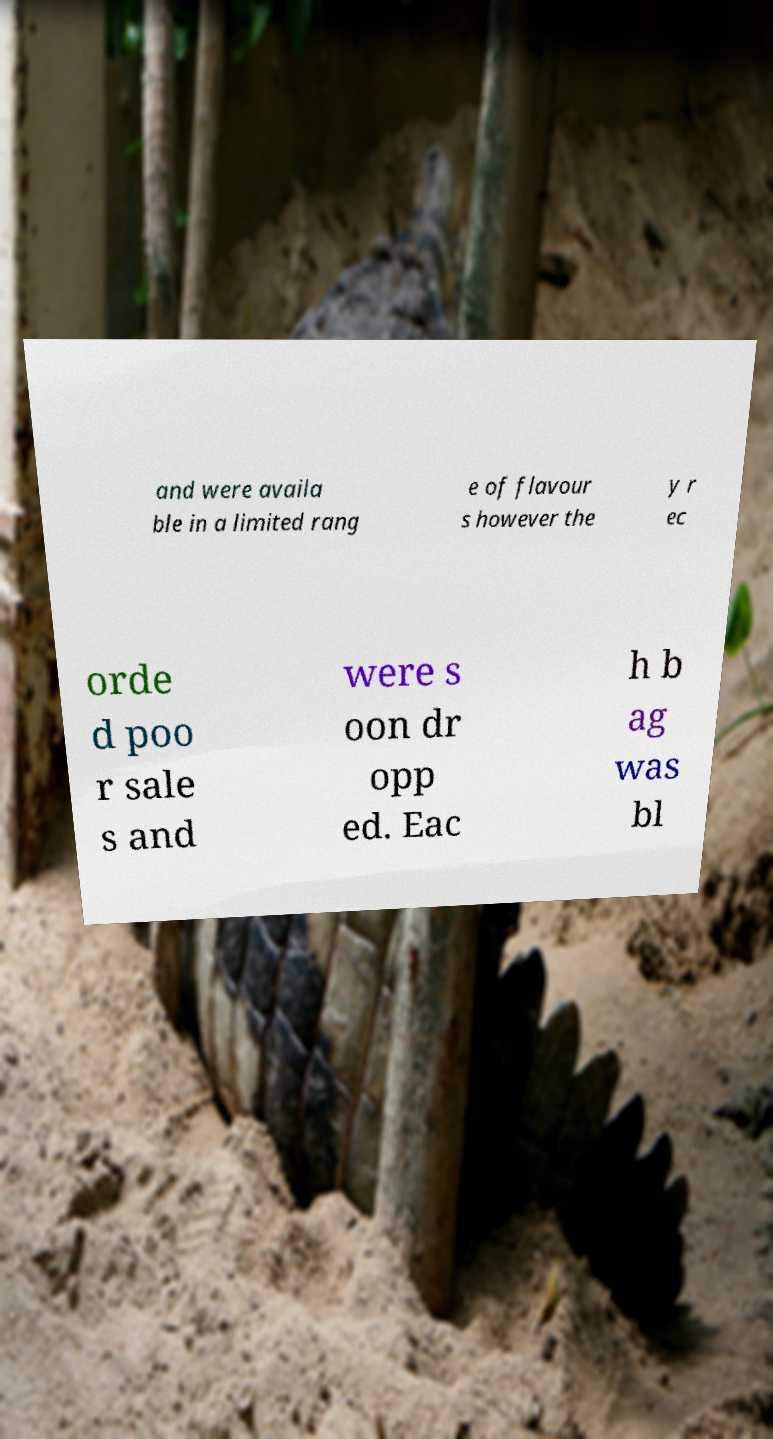Could you extract and type out the text from this image? and were availa ble in a limited rang e of flavour s however the y r ec orde d poo r sale s and were s oon dr opp ed. Eac h b ag was bl 